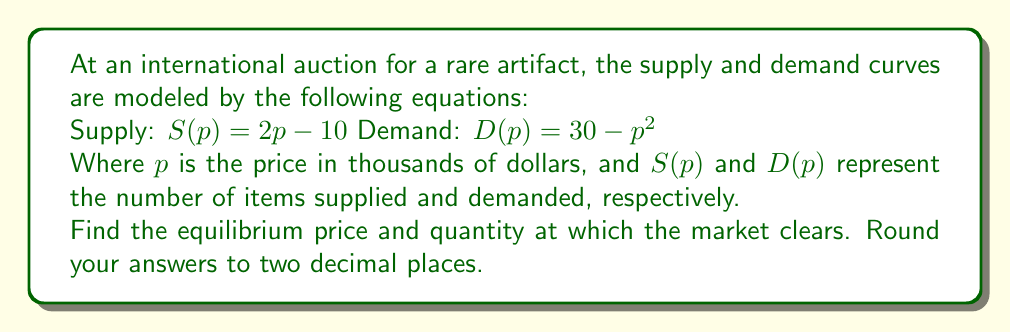Help me with this question. To find the equilibrium price and quantity, we need to find the intersection point of the supply and demand curves. This occurs when $S(p) = D(p)$.

1) Set up the equation:
   $2p - 10 = 30 - p^2$

2) Rearrange the equation:
   $p^2 + 2p - 40 = 0$

3) This is a quadratic equation. We can solve it using the quadratic formula:
   $p = \frac{-b \pm \sqrt{b^2 - 4ac}}{2a}$

   Where $a = 1$, $b = 2$, and $c = -40$

4) Substitute these values:
   $p = \frac{-2 \pm \sqrt{2^2 - 4(1)(-40)}}{2(1)}$
   $= \frac{-2 \pm \sqrt{4 + 160}}{2}$
   $= \frac{-2 \pm \sqrt{164}}{2}$
   $= \frac{-2 \pm 12.81}{2}$

5) This gives us two solutions:
   $p_1 = \frac{-2 + 12.81}{2} = 5.41$
   $p_2 = \frac{-2 - 12.81}{2} = -7.41$

6) Since price cannot be negative, we discard the negative solution.
   The equilibrium price is $5.41$ thousand dollars, or $5,410.

7) To find the equilibrium quantity, substitute this price into either the supply or demand equation:
   $S(5.41) = 2(5.41) - 10 = 0.82$

Therefore, the equilibrium quantity is 0.82 items (rounded to two decimal places).
Answer: Equilibrium price: $5.41 thousand dollars
Equilibrium quantity: 0.82 items 